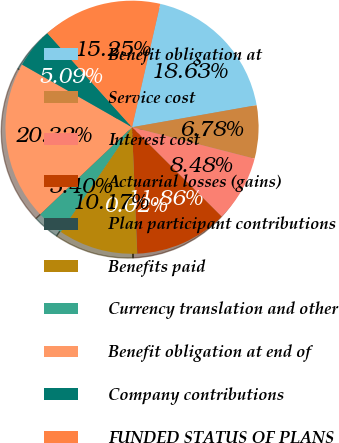Convert chart to OTSL. <chart><loc_0><loc_0><loc_500><loc_500><pie_chart><fcel>Benefit obligation at<fcel>Service cost<fcel>Interest cost<fcel>Actuarial losses (gains)<fcel>Plan participant contributions<fcel>Benefits paid<fcel>Currency translation and other<fcel>Benefit obligation at end of<fcel>Company contributions<fcel>FUNDED STATUS OF PLANS<nl><fcel>18.63%<fcel>6.78%<fcel>8.48%<fcel>11.86%<fcel>0.02%<fcel>10.17%<fcel>3.4%<fcel>20.32%<fcel>5.09%<fcel>15.25%<nl></chart> 